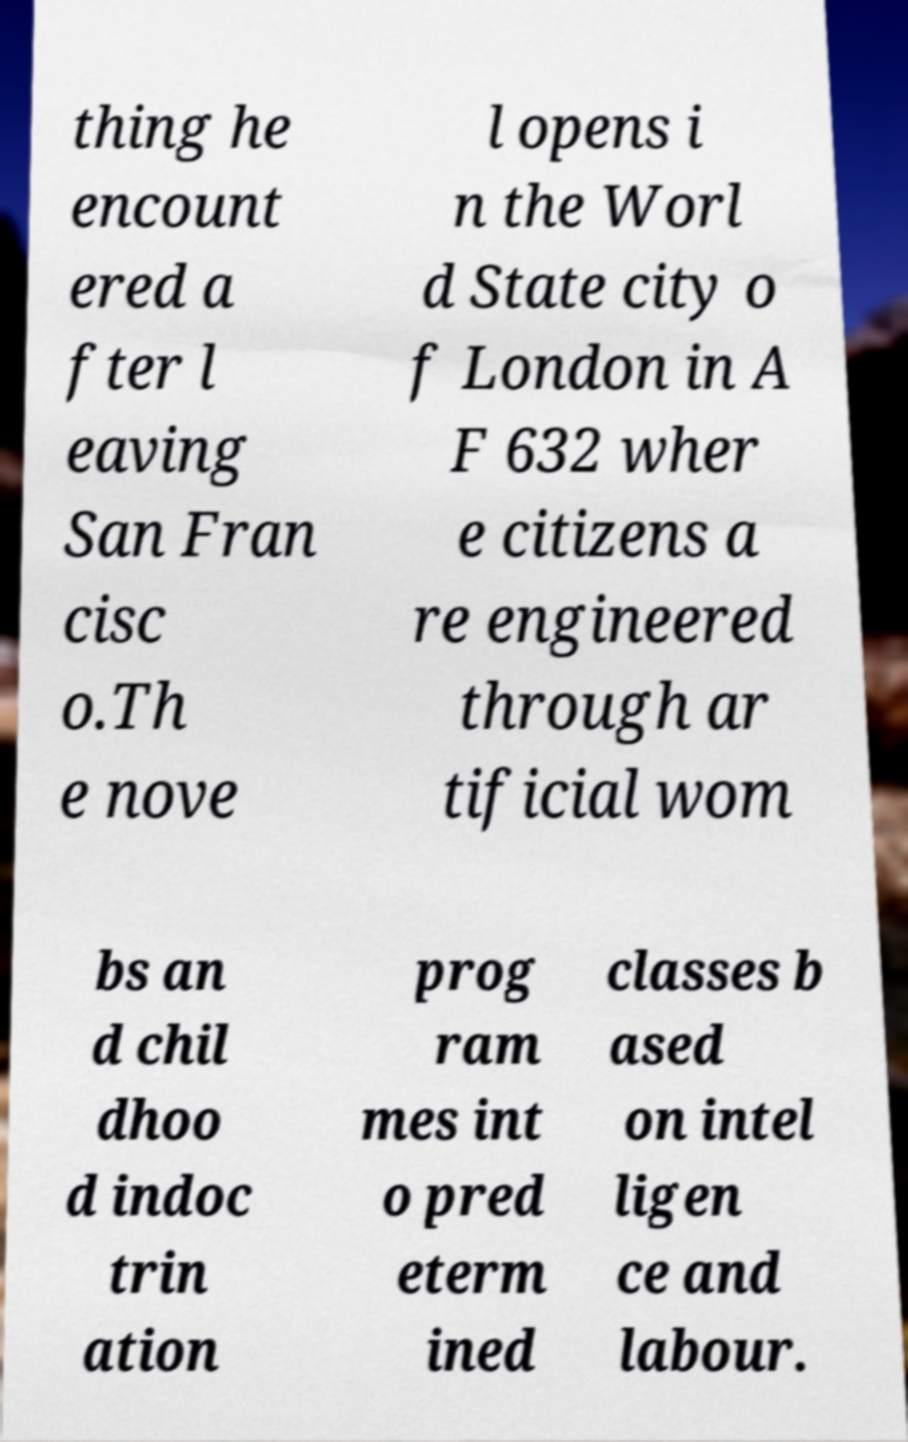Could you assist in decoding the text presented in this image and type it out clearly? thing he encount ered a fter l eaving San Fran cisc o.Th e nove l opens i n the Worl d State city o f London in A F 632 wher e citizens a re engineered through ar tificial wom bs an d chil dhoo d indoc trin ation prog ram mes int o pred eterm ined classes b ased on intel ligen ce and labour. 